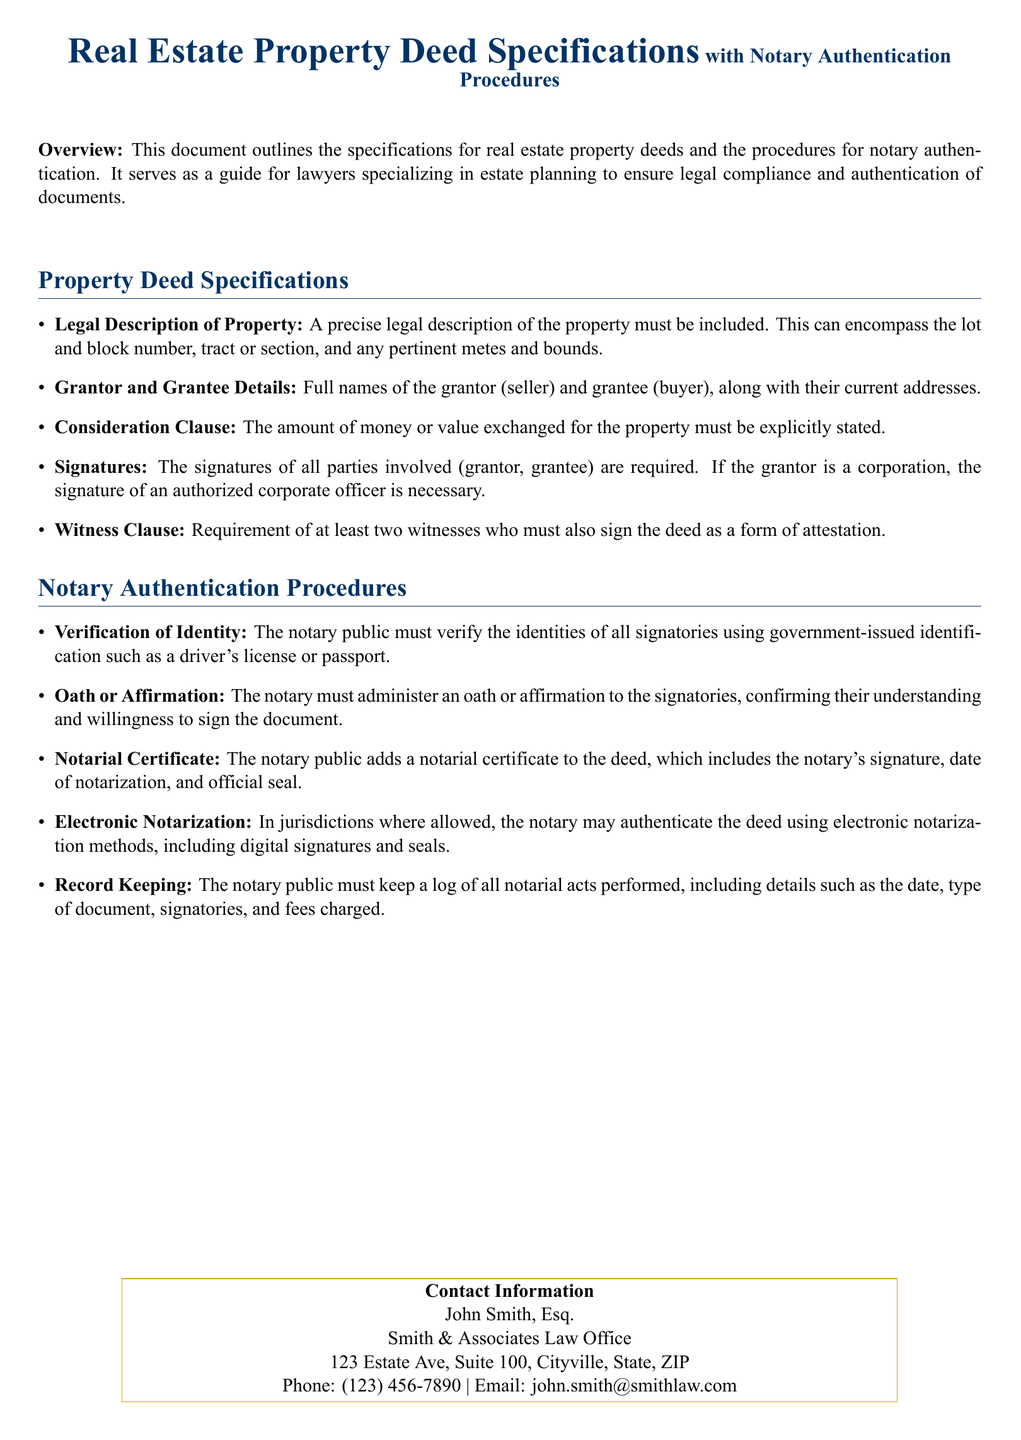what is the title of the document? The title of the document is specified at the beginning, indicating its focus on real estate and notary authentication.
Answer: Real Estate Property Deed Specifications with Notary Authentication Procedures who is the author of the document? The document provides the author's name, indicating contact for further information or assistance.
Answer: John Smith, Esq how many witnesses are required for the deed? The document states the requirement for witnesses in the specifications section.
Answer: At least two witnesses what should be included in the legal description of property? This information is detailed in the property deed specifications section, which outlines the components needed for compliance.
Answer: Lot and block number, tract or section, and any pertinent metes and bounds what identification must the notary verify? The authentication procedures specify the type of identification required for verification by the notary public.
Answer: Government-issued identification what is the purpose of the notarial certificate? The document explains that this certificate serves a specific function in the deedauthentication process.
Answer: To include the notary's signature, date of notarization, and official seal what kind of notarization methods are mentioned? The notary authentication procedures indicate different methods that may be used in the notarization process.
Answer: Electronic notarization what information must the notary keep in their log? The document specifies what details the notary must record for each notarial act.
Answer: Date, type of document, signatories, and fees charged 